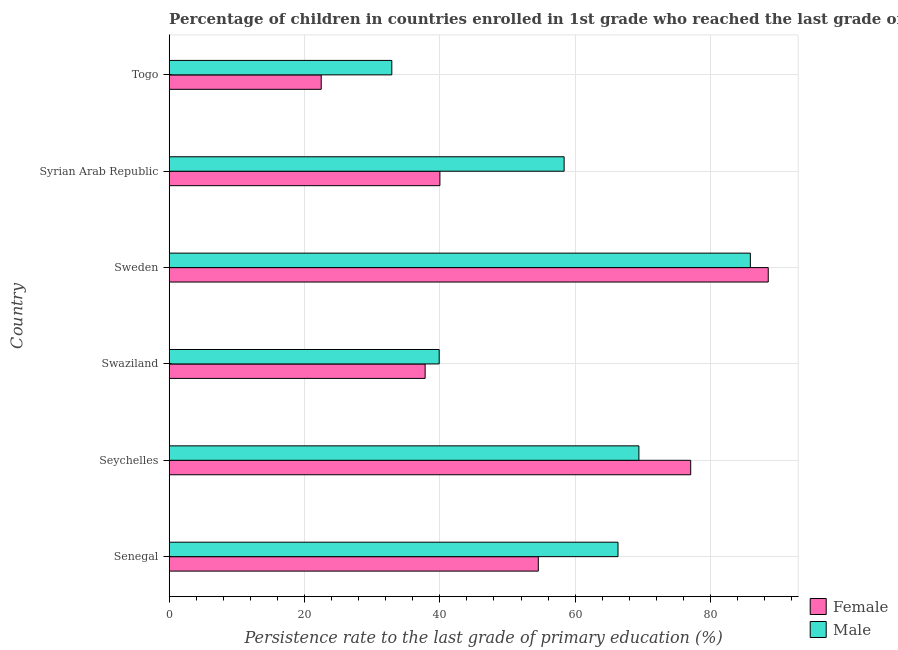How many groups of bars are there?
Provide a short and direct response. 6. Are the number of bars per tick equal to the number of legend labels?
Provide a short and direct response. Yes. How many bars are there on the 1st tick from the top?
Provide a short and direct response. 2. How many bars are there on the 5th tick from the bottom?
Keep it short and to the point. 2. In how many cases, is the number of bars for a given country not equal to the number of legend labels?
Provide a short and direct response. 0. What is the persistence rate of male students in Senegal?
Your response must be concise. 66.34. Across all countries, what is the maximum persistence rate of male students?
Your answer should be very brief. 85.9. Across all countries, what is the minimum persistence rate of female students?
Your answer should be compact. 22.47. In which country was the persistence rate of male students maximum?
Your answer should be compact. Sweden. In which country was the persistence rate of male students minimum?
Provide a succinct answer. Togo. What is the total persistence rate of male students in the graph?
Your answer should be very brief. 352.86. What is the difference between the persistence rate of female students in Senegal and that in Swaziland?
Your answer should be very brief. 16.73. What is the difference between the persistence rate of female students in Syrian Arab Republic and the persistence rate of male students in Senegal?
Ensure brevity in your answer.  -26.33. What is the average persistence rate of male students per country?
Provide a succinct answer. 58.81. What is the difference between the persistence rate of female students and persistence rate of male students in Syrian Arab Republic?
Make the answer very short. -18.36. In how many countries, is the persistence rate of male students greater than 12 %?
Provide a short and direct response. 6. What is the ratio of the persistence rate of male students in Seychelles to that in Sweden?
Provide a short and direct response. 0.81. What is the difference between the highest and the second highest persistence rate of female students?
Give a very brief answer. 11.46. What is the difference between the highest and the lowest persistence rate of female students?
Keep it short and to the point. 66.08. In how many countries, is the persistence rate of male students greater than the average persistence rate of male students taken over all countries?
Make the answer very short. 3. Is the sum of the persistence rate of male students in Senegal and Sweden greater than the maximum persistence rate of female students across all countries?
Provide a short and direct response. Yes. What does the 1st bar from the bottom in Seychelles represents?
Make the answer very short. Female. Are all the bars in the graph horizontal?
Ensure brevity in your answer.  Yes. How many countries are there in the graph?
Make the answer very short. 6. Are the values on the major ticks of X-axis written in scientific E-notation?
Offer a terse response. No. Does the graph contain any zero values?
Provide a succinct answer. No. How many legend labels are there?
Make the answer very short. 2. What is the title of the graph?
Provide a succinct answer. Percentage of children in countries enrolled in 1st grade who reached the last grade of primary education. What is the label or title of the X-axis?
Provide a short and direct response. Persistence rate to the last grade of primary education (%). What is the label or title of the Y-axis?
Ensure brevity in your answer.  Country. What is the Persistence rate to the last grade of primary education (%) in Female in Senegal?
Make the answer very short. 54.56. What is the Persistence rate to the last grade of primary education (%) of Male in Senegal?
Make the answer very short. 66.34. What is the Persistence rate to the last grade of primary education (%) in Female in Seychelles?
Make the answer very short. 77.08. What is the Persistence rate to the last grade of primary education (%) of Male in Seychelles?
Your response must be concise. 69.43. What is the Persistence rate to the last grade of primary education (%) in Female in Swaziland?
Give a very brief answer. 37.83. What is the Persistence rate to the last grade of primary education (%) of Male in Swaziland?
Provide a succinct answer. 39.91. What is the Persistence rate to the last grade of primary education (%) in Female in Sweden?
Make the answer very short. 88.55. What is the Persistence rate to the last grade of primary education (%) of Male in Sweden?
Your answer should be compact. 85.9. What is the Persistence rate to the last grade of primary education (%) of Female in Syrian Arab Republic?
Offer a terse response. 40.01. What is the Persistence rate to the last grade of primary education (%) in Male in Syrian Arab Republic?
Give a very brief answer. 58.37. What is the Persistence rate to the last grade of primary education (%) of Female in Togo?
Offer a very short reply. 22.47. What is the Persistence rate to the last grade of primary education (%) of Male in Togo?
Give a very brief answer. 32.91. Across all countries, what is the maximum Persistence rate to the last grade of primary education (%) in Female?
Keep it short and to the point. 88.55. Across all countries, what is the maximum Persistence rate to the last grade of primary education (%) in Male?
Ensure brevity in your answer.  85.9. Across all countries, what is the minimum Persistence rate to the last grade of primary education (%) in Female?
Ensure brevity in your answer.  22.47. Across all countries, what is the minimum Persistence rate to the last grade of primary education (%) of Male?
Your answer should be compact. 32.91. What is the total Persistence rate to the last grade of primary education (%) of Female in the graph?
Ensure brevity in your answer.  320.5. What is the total Persistence rate to the last grade of primary education (%) in Male in the graph?
Ensure brevity in your answer.  352.86. What is the difference between the Persistence rate to the last grade of primary education (%) of Female in Senegal and that in Seychelles?
Your answer should be very brief. -22.52. What is the difference between the Persistence rate to the last grade of primary education (%) of Male in Senegal and that in Seychelles?
Make the answer very short. -3.09. What is the difference between the Persistence rate to the last grade of primary education (%) of Female in Senegal and that in Swaziland?
Keep it short and to the point. 16.73. What is the difference between the Persistence rate to the last grade of primary education (%) of Male in Senegal and that in Swaziland?
Provide a succinct answer. 26.43. What is the difference between the Persistence rate to the last grade of primary education (%) of Female in Senegal and that in Sweden?
Provide a short and direct response. -33.99. What is the difference between the Persistence rate to the last grade of primary education (%) in Male in Senegal and that in Sweden?
Provide a short and direct response. -19.56. What is the difference between the Persistence rate to the last grade of primary education (%) of Female in Senegal and that in Syrian Arab Republic?
Offer a terse response. 14.55. What is the difference between the Persistence rate to the last grade of primary education (%) in Male in Senegal and that in Syrian Arab Republic?
Offer a terse response. 7.97. What is the difference between the Persistence rate to the last grade of primary education (%) in Female in Senegal and that in Togo?
Your response must be concise. 32.09. What is the difference between the Persistence rate to the last grade of primary education (%) in Male in Senegal and that in Togo?
Your answer should be compact. 33.44. What is the difference between the Persistence rate to the last grade of primary education (%) of Female in Seychelles and that in Swaziland?
Provide a short and direct response. 39.25. What is the difference between the Persistence rate to the last grade of primary education (%) in Male in Seychelles and that in Swaziland?
Keep it short and to the point. 29.52. What is the difference between the Persistence rate to the last grade of primary education (%) of Female in Seychelles and that in Sweden?
Ensure brevity in your answer.  -11.46. What is the difference between the Persistence rate to the last grade of primary education (%) in Male in Seychelles and that in Sweden?
Provide a succinct answer. -16.47. What is the difference between the Persistence rate to the last grade of primary education (%) in Female in Seychelles and that in Syrian Arab Republic?
Give a very brief answer. 37.07. What is the difference between the Persistence rate to the last grade of primary education (%) of Male in Seychelles and that in Syrian Arab Republic?
Provide a short and direct response. 11.05. What is the difference between the Persistence rate to the last grade of primary education (%) in Female in Seychelles and that in Togo?
Your answer should be compact. 54.61. What is the difference between the Persistence rate to the last grade of primary education (%) in Male in Seychelles and that in Togo?
Your answer should be compact. 36.52. What is the difference between the Persistence rate to the last grade of primary education (%) of Female in Swaziland and that in Sweden?
Offer a terse response. -50.71. What is the difference between the Persistence rate to the last grade of primary education (%) of Male in Swaziland and that in Sweden?
Make the answer very short. -45.99. What is the difference between the Persistence rate to the last grade of primary education (%) in Female in Swaziland and that in Syrian Arab Republic?
Your answer should be compact. -2.18. What is the difference between the Persistence rate to the last grade of primary education (%) in Male in Swaziland and that in Syrian Arab Republic?
Your answer should be compact. -18.47. What is the difference between the Persistence rate to the last grade of primary education (%) in Female in Swaziland and that in Togo?
Your answer should be compact. 15.36. What is the difference between the Persistence rate to the last grade of primary education (%) of Male in Swaziland and that in Togo?
Ensure brevity in your answer.  7. What is the difference between the Persistence rate to the last grade of primary education (%) of Female in Sweden and that in Syrian Arab Republic?
Offer a very short reply. 48.53. What is the difference between the Persistence rate to the last grade of primary education (%) in Male in Sweden and that in Syrian Arab Republic?
Offer a very short reply. 27.53. What is the difference between the Persistence rate to the last grade of primary education (%) of Female in Sweden and that in Togo?
Make the answer very short. 66.08. What is the difference between the Persistence rate to the last grade of primary education (%) of Male in Sweden and that in Togo?
Offer a terse response. 53. What is the difference between the Persistence rate to the last grade of primary education (%) in Female in Syrian Arab Republic and that in Togo?
Your answer should be very brief. 17.54. What is the difference between the Persistence rate to the last grade of primary education (%) of Male in Syrian Arab Republic and that in Togo?
Keep it short and to the point. 25.47. What is the difference between the Persistence rate to the last grade of primary education (%) of Female in Senegal and the Persistence rate to the last grade of primary education (%) of Male in Seychelles?
Your answer should be compact. -14.87. What is the difference between the Persistence rate to the last grade of primary education (%) of Female in Senegal and the Persistence rate to the last grade of primary education (%) of Male in Swaziland?
Offer a very short reply. 14.65. What is the difference between the Persistence rate to the last grade of primary education (%) in Female in Senegal and the Persistence rate to the last grade of primary education (%) in Male in Sweden?
Provide a short and direct response. -31.34. What is the difference between the Persistence rate to the last grade of primary education (%) in Female in Senegal and the Persistence rate to the last grade of primary education (%) in Male in Syrian Arab Republic?
Offer a terse response. -3.81. What is the difference between the Persistence rate to the last grade of primary education (%) in Female in Senegal and the Persistence rate to the last grade of primary education (%) in Male in Togo?
Keep it short and to the point. 21.65. What is the difference between the Persistence rate to the last grade of primary education (%) of Female in Seychelles and the Persistence rate to the last grade of primary education (%) of Male in Swaziland?
Provide a short and direct response. 37.18. What is the difference between the Persistence rate to the last grade of primary education (%) of Female in Seychelles and the Persistence rate to the last grade of primary education (%) of Male in Sweden?
Keep it short and to the point. -8.82. What is the difference between the Persistence rate to the last grade of primary education (%) of Female in Seychelles and the Persistence rate to the last grade of primary education (%) of Male in Syrian Arab Republic?
Your response must be concise. 18.71. What is the difference between the Persistence rate to the last grade of primary education (%) in Female in Seychelles and the Persistence rate to the last grade of primary education (%) in Male in Togo?
Ensure brevity in your answer.  44.18. What is the difference between the Persistence rate to the last grade of primary education (%) of Female in Swaziland and the Persistence rate to the last grade of primary education (%) of Male in Sweden?
Provide a succinct answer. -48.07. What is the difference between the Persistence rate to the last grade of primary education (%) in Female in Swaziland and the Persistence rate to the last grade of primary education (%) in Male in Syrian Arab Republic?
Offer a very short reply. -20.54. What is the difference between the Persistence rate to the last grade of primary education (%) of Female in Swaziland and the Persistence rate to the last grade of primary education (%) of Male in Togo?
Give a very brief answer. 4.93. What is the difference between the Persistence rate to the last grade of primary education (%) of Female in Sweden and the Persistence rate to the last grade of primary education (%) of Male in Syrian Arab Republic?
Provide a short and direct response. 30.17. What is the difference between the Persistence rate to the last grade of primary education (%) in Female in Sweden and the Persistence rate to the last grade of primary education (%) in Male in Togo?
Your answer should be compact. 55.64. What is the difference between the Persistence rate to the last grade of primary education (%) of Female in Syrian Arab Republic and the Persistence rate to the last grade of primary education (%) of Male in Togo?
Your response must be concise. 7.11. What is the average Persistence rate to the last grade of primary education (%) in Female per country?
Your response must be concise. 53.42. What is the average Persistence rate to the last grade of primary education (%) in Male per country?
Ensure brevity in your answer.  58.81. What is the difference between the Persistence rate to the last grade of primary education (%) in Female and Persistence rate to the last grade of primary education (%) in Male in Senegal?
Ensure brevity in your answer.  -11.78. What is the difference between the Persistence rate to the last grade of primary education (%) of Female and Persistence rate to the last grade of primary education (%) of Male in Seychelles?
Your answer should be compact. 7.66. What is the difference between the Persistence rate to the last grade of primary education (%) in Female and Persistence rate to the last grade of primary education (%) in Male in Swaziland?
Offer a terse response. -2.08. What is the difference between the Persistence rate to the last grade of primary education (%) of Female and Persistence rate to the last grade of primary education (%) of Male in Sweden?
Provide a succinct answer. 2.64. What is the difference between the Persistence rate to the last grade of primary education (%) of Female and Persistence rate to the last grade of primary education (%) of Male in Syrian Arab Republic?
Provide a succinct answer. -18.36. What is the difference between the Persistence rate to the last grade of primary education (%) in Female and Persistence rate to the last grade of primary education (%) in Male in Togo?
Provide a short and direct response. -10.44. What is the ratio of the Persistence rate to the last grade of primary education (%) in Female in Senegal to that in Seychelles?
Your response must be concise. 0.71. What is the ratio of the Persistence rate to the last grade of primary education (%) of Male in Senegal to that in Seychelles?
Give a very brief answer. 0.96. What is the ratio of the Persistence rate to the last grade of primary education (%) of Female in Senegal to that in Swaziland?
Offer a very short reply. 1.44. What is the ratio of the Persistence rate to the last grade of primary education (%) in Male in Senegal to that in Swaziland?
Give a very brief answer. 1.66. What is the ratio of the Persistence rate to the last grade of primary education (%) of Female in Senegal to that in Sweden?
Provide a succinct answer. 0.62. What is the ratio of the Persistence rate to the last grade of primary education (%) of Male in Senegal to that in Sweden?
Give a very brief answer. 0.77. What is the ratio of the Persistence rate to the last grade of primary education (%) in Female in Senegal to that in Syrian Arab Republic?
Provide a short and direct response. 1.36. What is the ratio of the Persistence rate to the last grade of primary education (%) in Male in Senegal to that in Syrian Arab Republic?
Your answer should be compact. 1.14. What is the ratio of the Persistence rate to the last grade of primary education (%) of Female in Senegal to that in Togo?
Keep it short and to the point. 2.43. What is the ratio of the Persistence rate to the last grade of primary education (%) of Male in Senegal to that in Togo?
Your response must be concise. 2.02. What is the ratio of the Persistence rate to the last grade of primary education (%) of Female in Seychelles to that in Swaziland?
Keep it short and to the point. 2.04. What is the ratio of the Persistence rate to the last grade of primary education (%) in Male in Seychelles to that in Swaziland?
Give a very brief answer. 1.74. What is the ratio of the Persistence rate to the last grade of primary education (%) of Female in Seychelles to that in Sweden?
Ensure brevity in your answer.  0.87. What is the ratio of the Persistence rate to the last grade of primary education (%) of Male in Seychelles to that in Sweden?
Offer a very short reply. 0.81. What is the ratio of the Persistence rate to the last grade of primary education (%) of Female in Seychelles to that in Syrian Arab Republic?
Make the answer very short. 1.93. What is the ratio of the Persistence rate to the last grade of primary education (%) of Male in Seychelles to that in Syrian Arab Republic?
Your answer should be very brief. 1.19. What is the ratio of the Persistence rate to the last grade of primary education (%) in Female in Seychelles to that in Togo?
Your answer should be very brief. 3.43. What is the ratio of the Persistence rate to the last grade of primary education (%) of Male in Seychelles to that in Togo?
Provide a succinct answer. 2.11. What is the ratio of the Persistence rate to the last grade of primary education (%) of Female in Swaziland to that in Sweden?
Your answer should be very brief. 0.43. What is the ratio of the Persistence rate to the last grade of primary education (%) of Male in Swaziland to that in Sweden?
Your answer should be compact. 0.46. What is the ratio of the Persistence rate to the last grade of primary education (%) of Female in Swaziland to that in Syrian Arab Republic?
Provide a short and direct response. 0.95. What is the ratio of the Persistence rate to the last grade of primary education (%) of Male in Swaziland to that in Syrian Arab Republic?
Offer a very short reply. 0.68. What is the ratio of the Persistence rate to the last grade of primary education (%) of Female in Swaziland to that in Togo?
Offer a terse response. 1.68. What is the ratio of the Persistence rate to the last grade of primary education (%) of Male in Swaziland to that in Togo?
Offer a terse response. 1.21. What is the ratio of the Persistence rate to the last grade of primary education (%) of Female in Sweden to that in Syrian Arab Republic?
Keep it short and to the point. 2.21. What is the ratio of the Persistence rate to the last grade of primary education (%) of Male in Sweden to that in Syrian Arab Republic?
Provide a short and direct response. 1.47. What is the ratio of the Persistence rate to the last grade of primary education (%) of Female in Sweden to that in Togo?
Your answer should be compact. 3.94. What is the ratio of the Persistence rate to the last grade of primary education (%) in Male in Sweden to that in Togo?
Your answer should be very brief. 2.61. What is the ratio of the Persistence rate to the last grade of primary education (%) of Female in Syrian Arab Republic to that in Togo?
Provide a short and direct response. 1.78. What is the ratio of the Persistence rate to the last grade of primary education (%) of Male in Syrian Arab Republic to that in Togo?
Your answer should be compact. 1.77. What is the difference between the highest and the second highest Persistence rate to the last grade of primary education (%) in Female?
Provide a short and direct response. 11.46. What is the difference between the highest and the second highest Persistence rate to the last grade of primary education (%) in Male?
Your response must be concise. 16.47. What is the difference between the highest and the lowest Persistence rate to the last grade of primary education (%) of Female?
Make the answer very short. 66.08. What is the difference between the highest and the lowest Persistence rate to the last grade of primary education (%) of Male?
Give a very brief answer. 53. 